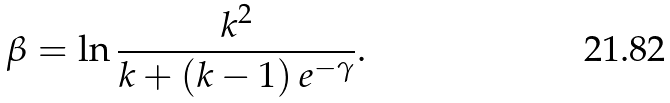<formula> <loc_0><loc_0><loc_500><loc_500>\beta = \ln \frac { k ^ { 2 } } { k + ( k - 1 ) \, e ^ { - \gamma } } .</formula> 